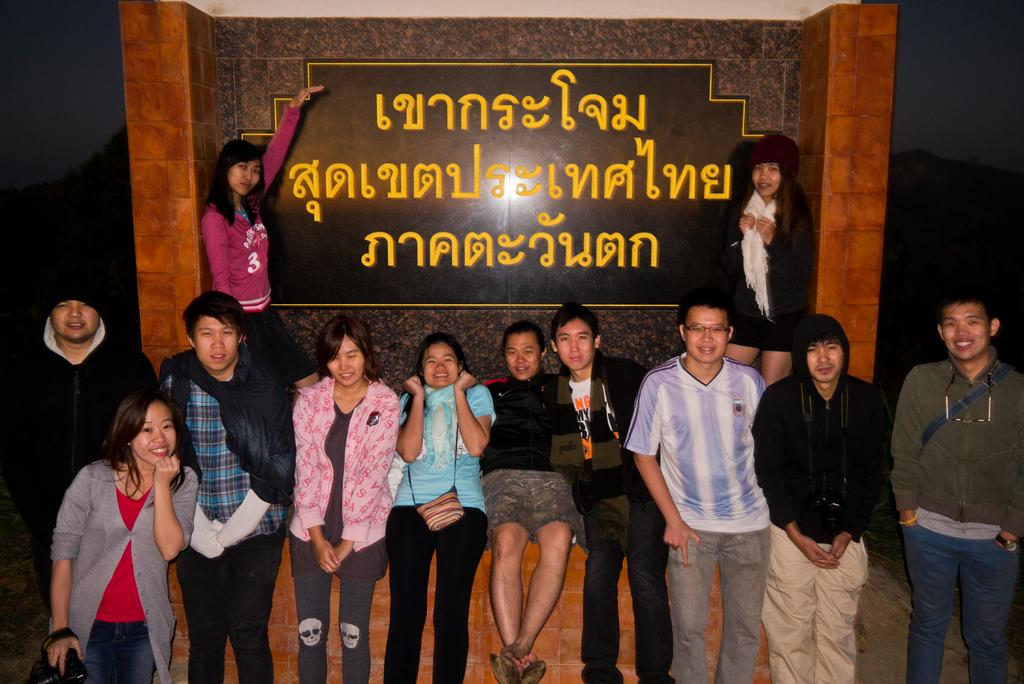What is located in the foreground of the image? There are people in the foreground of the image. What can be seen in the background of the image? There are two women standing in the background of the image. What type of structure is present in the image? There is a wall in the image. What is written or displayed on the board in the image? There is a board with some text in the image. What type of shade is covering the tent in the image? There is no tent or shade present in the image. What shape is the square that the women are standing on in the image? There is no square mentioned in the image; it only states that there are two women standing in the background. 